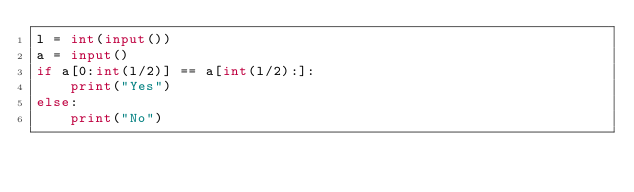<code> <loc_0><loc_0><loc_500><loc_500><_Python_>l = int(input())
a = input()
if a[0:int(l/2)] == a[int(l/2):]:
    print("Yes")
else:
    print("No")
</code> 